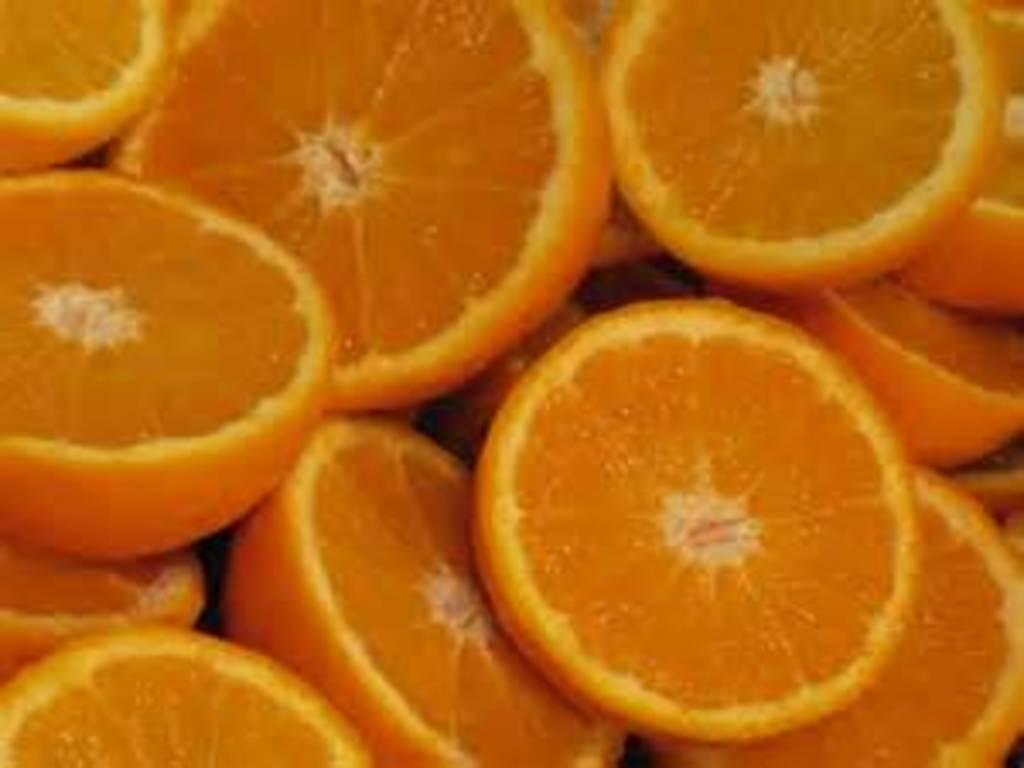Can you describe this image briefly? In this image we can see a group of sliced oranges. 